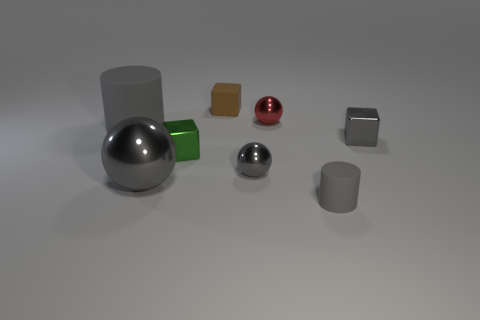Add 2 big metallic spheres. How many objects exist? 10 Subtract all cylinders. How many objects are left? 6 Add 7 red spheres. How many red spheres are left? 8 Add 5 big brown matte cylinders. How many big brown matte cylinders exist? 5 Subtract 1 green blocks. How many objects are left? 7 Subtract all brown rubber spheres. Subtract all gray cylinders. How many objects are left? 6 